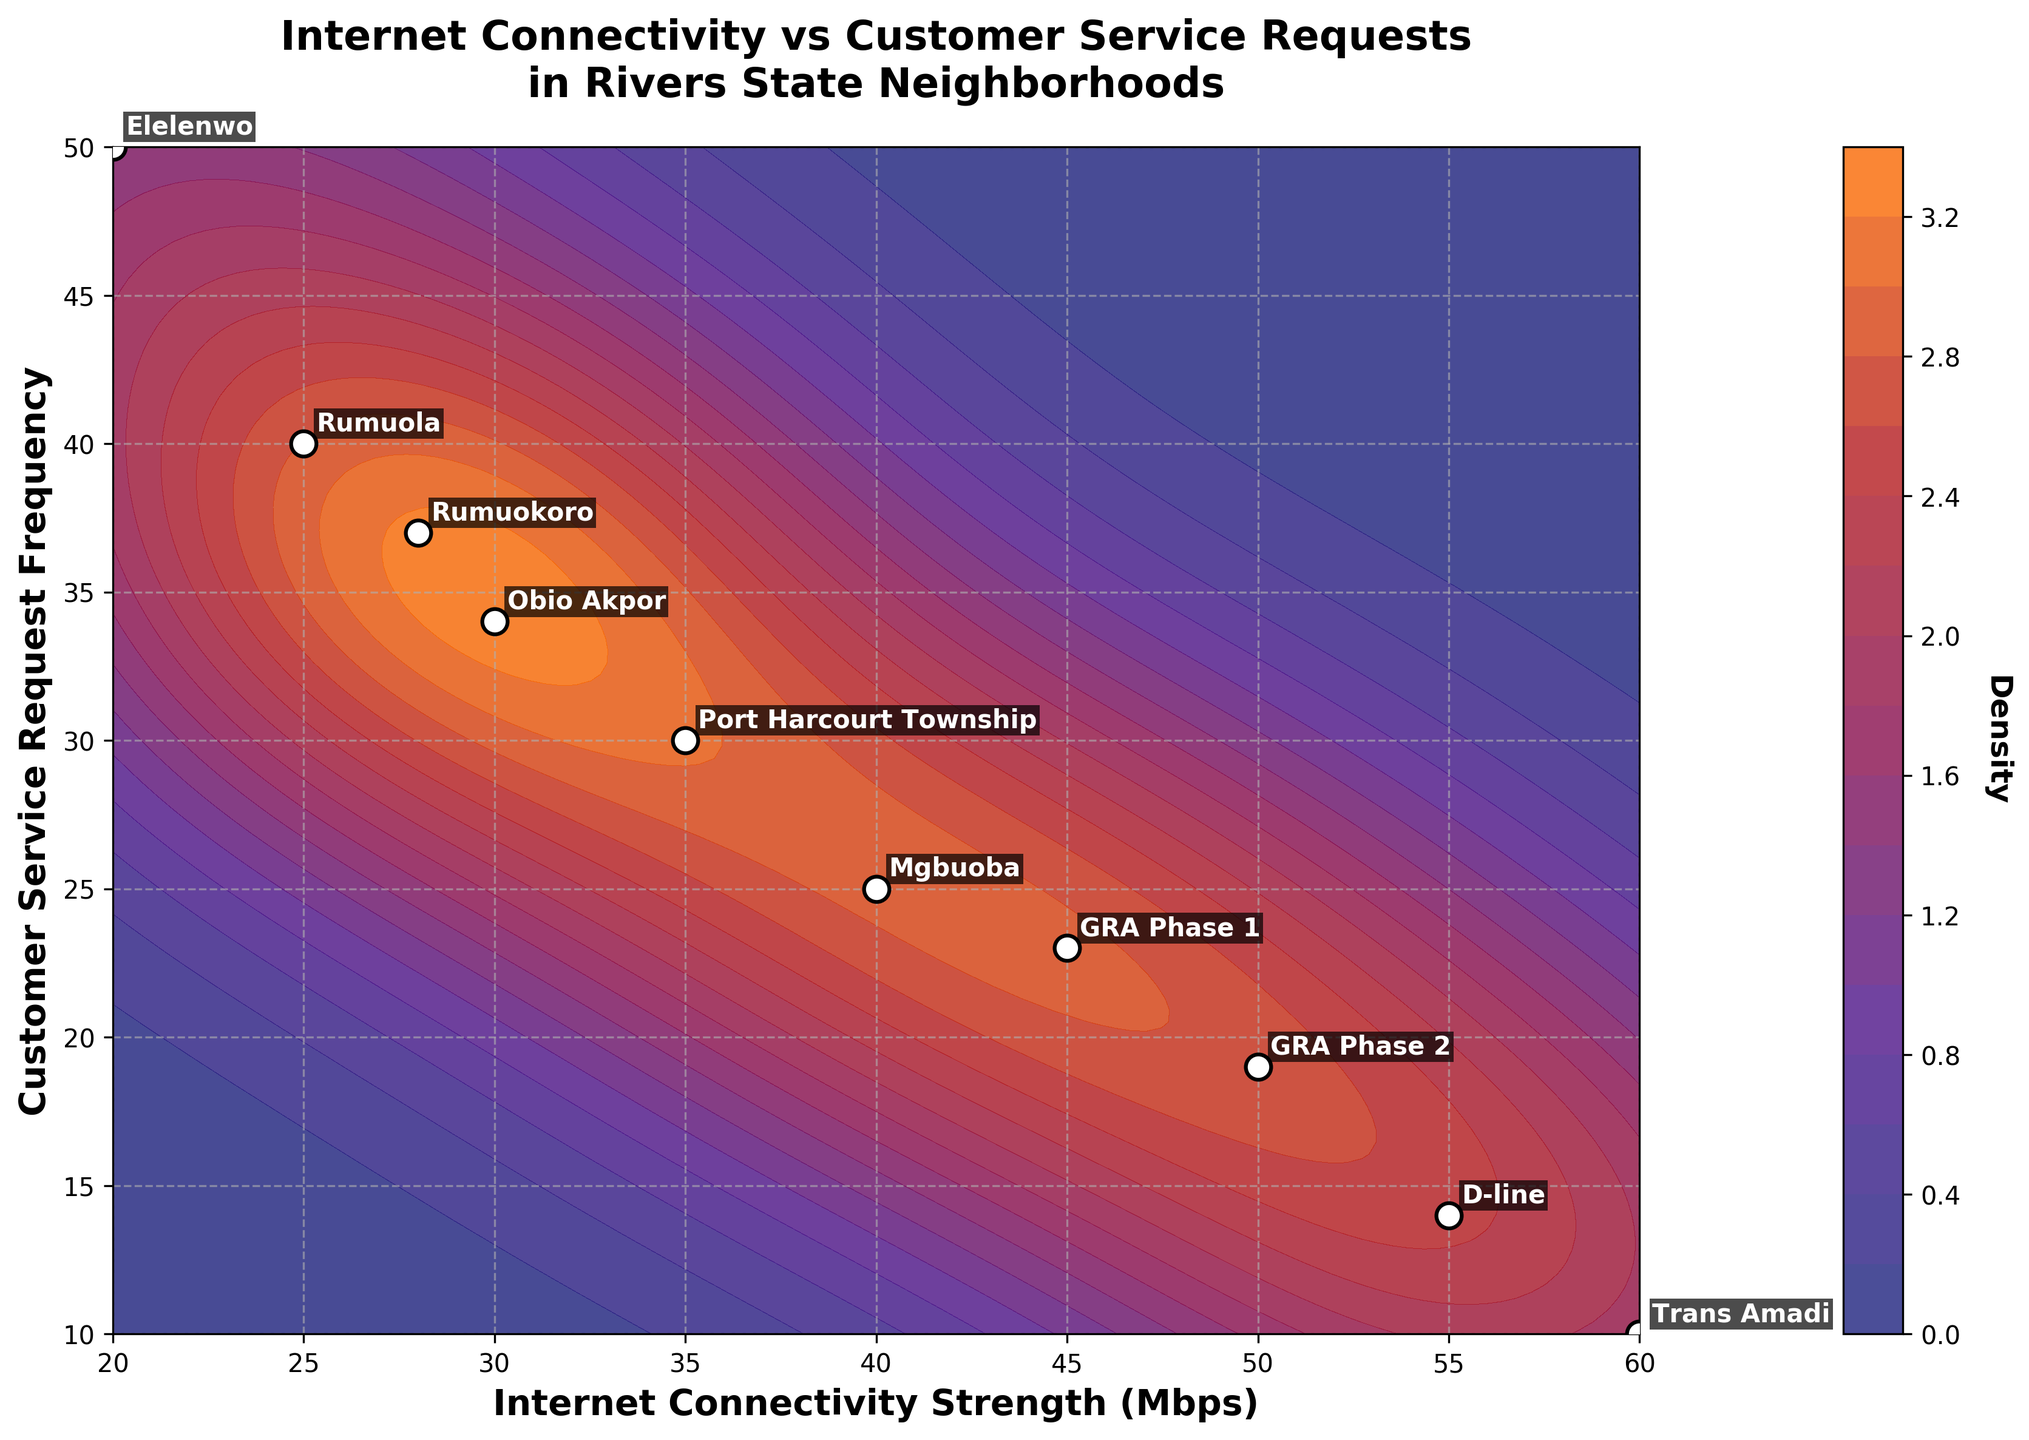What is the title of the plot? The title of the plot is usually located at the top of the figure and provides a summary of what the plot is about.
Answer: Internet Connectivity vs Customer Service Requests in Rivers State Neighborhoods What are the x and y axes representing in this plot? The x-axis and y-axis labels indicate what each axis represents.
Answer: The x-axis represents Internet Connectivity Strength (Mbps) and the y-axis represents Customer Service Request Frequency Which neighborhood has the highest Internet connectivity strength? The highest point on the x-axis represents the neighborhood with the highest Internet connectivity strength. The annotations on the plot indicate the neighborhood names.
Answer: Trans Amadi Which neighborhood has the highest customer service request frequency? The highest point on the y-axis represents the neighborhood with the highest customer service request frequency. The annotations on the plot indicate the neighborhood names.
Answer: Elelenwo What is the relationship between Internet connectivity strength and customer service request frequency in GRA Phase 1? Look for the point labeled "GRA Phase 1" on the plot and check its coordinates on the x and y axes.
Answer: Internet connectivity strength is 45 Mbps and customer service request frequency is 23 Which neighborhood has the lowest customer service request frequency? The lowest point on the y-axis represents the neighborhood with the lowest customer service request frequency. The annotations on the plot indicate the neighborhood names.
Answer: Trans Amadi Compare the Internet connectivity strength between GRA Phase 2 and D-line. Which one is higher? Locate the points for GRA Phase 2 and D-line, then compare their values on the x-axis, which represents Internet connectivity strength.
Answer: D-line How does the customer service request frequency in Obio Akpor compare to that in Mgbuoba? Locate the points for Obio Akpor and Mgbuoba and compare their values on the y-axis, which represents customer service request frequency.
Answer: Obio Akpor has a higher customer service request frequency than Mgbuoba Which neighborhood has a higher Internet connectivity strength, Rumuola or Rumuokoro? Locate the points for Rumuola and Rumuokoro on the plot and compare their x-axis values.
Answer: Rumuokoro What can be inferred about the density in areas with high connectivity strength and low request frequency? Observe the coloration of the contour plot in the regions of high Internet connectivity strength and low customer service request frequency to determine the density pattern.
Answer: These areas show higher density, indicating more neighborhoods with this characteristic 